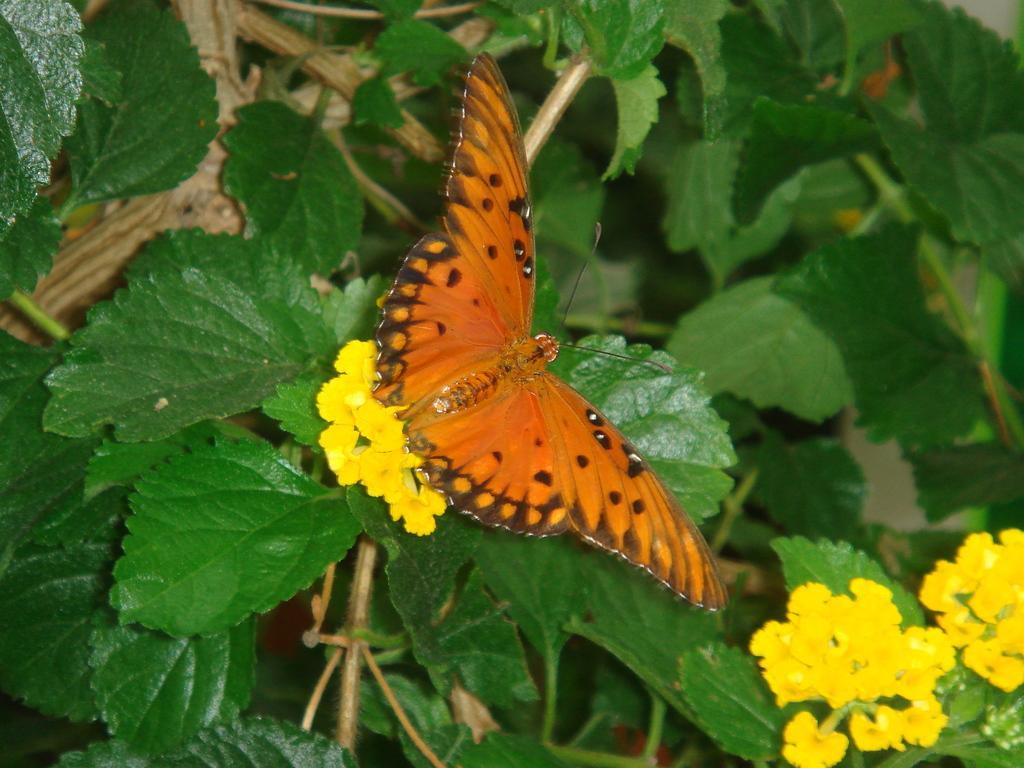Can you describe this image briefly? In the image there are stems with leaves and flowers. There is a butterfly on the flowers. 